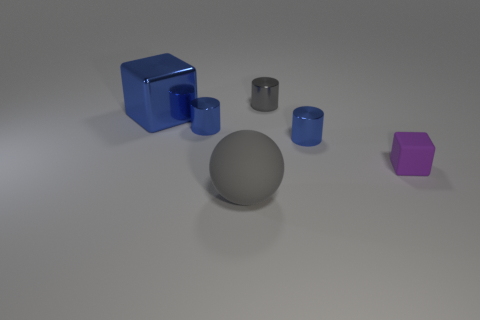Subtract all purple spheres. Subtract all purple cylinders. How many spheres are left? 1 Add 1 brown things. How many objects exist? 7 Subtract all blocks. How many objects are left? 4 Add 5 tiny gray things. How many tiny gray things exist? 6 Subtract 1 gray cylinders. How many objects are left? 5 Subtract all large green metallic cubes. Subtract all blue cylinders. How many objects are left? 4 Add 6 small shiny things. How many small shiny things are left? 9 